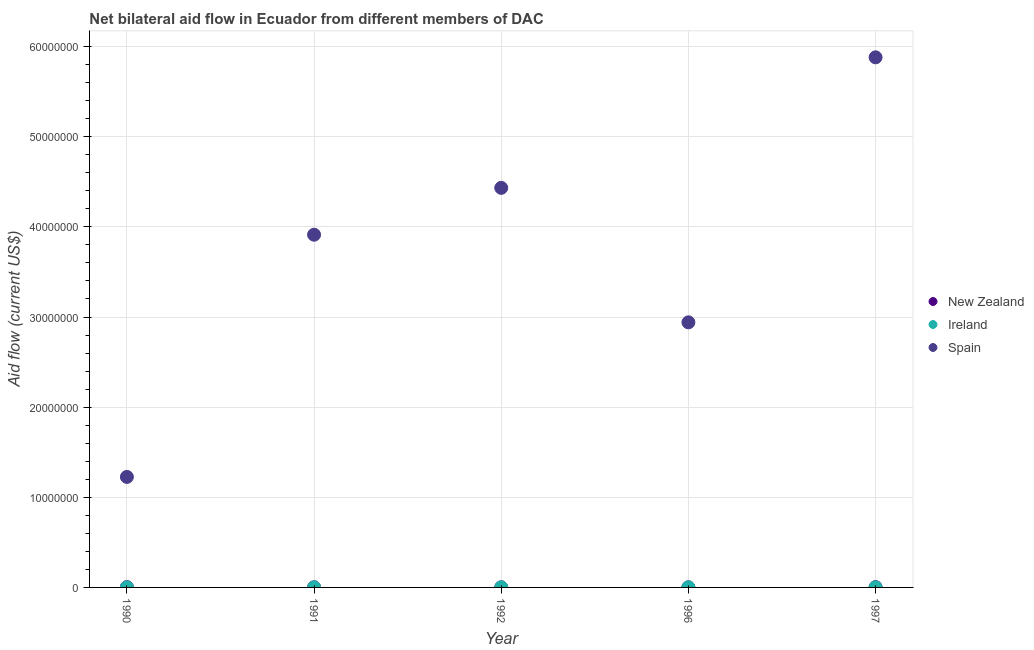Is the number of dotlines equal to the number of legend labels?
Your response must be concise. Yes. What is the amount of aid provided by new zealand in 1990?
Provide a succinct answer. 3.00e+04. Across all years, what is the maximum amount of aid provided by spain?
Offer a very short reply. 5.88e+07. Across all years, what is the minimum amount of aid provided by new zealand?
Make the answer very short. 10000. In which year was the amount of aid provided by new zealand maximum?
Your answer should be compact. 1990. In which year was the amount of aid provided by ireland minimum?
Your response must be concise. 1990. What is the total amount of aid provided by new zealand in the graph?
Provide a short and direct response. 9.00e+04. What is the difference between the amount of aid provided by spain in 1997 and the amount of aid provided by ireland in 1991?
Offer a terse response. 5.88e+07. In the year 1990, what is the difference between the amount of aid provided by spain and amount of aid provided by new zealand?
Your answer should be very brief. 1.22e+07. In how many years, is the amount of aid provided by new zealand greater than 14000000 US$?
Provide a succinct answer. 0. Is the amount of aid provided by ireland in 1991 less than that in 1992?
Keep it short and to the point. No. Is the difference between the amount of aid provided by ireland in 1991 and 1996 greater than the difference between the amount of aid provided by spain in 1991 and 1996?
Offer a very short reply. No. What is the difference between the highest and the lowest amount of aid provided by spain?
Your answer should be compact. 4.66e+07. Is the sum of the amount of aid provided by new zealand in 1991 and 1996 greater than the maximum amount of aid provided by ireland across all years?
Make the answer very short. Yes. Does the amount of aid provided by new zealand monotonically increase over the years?
Make the answer very short. No. What is the difference between two consecutive major ticks on the Y-axis?
Make the answer very short. 1.00e+07. Are the values on the major ticks of Y-axis written in scientific E-notation?
Keep it short and to the point. No. Does the graph contain any zero values?
Make the answer very short. No. Where does the legend appear in the graph?
Offer a very short reply. Center right. What is the title of the graph?
Your answer should be compact. Net bilateral aid flow in Ecuador from different members of DAC. What is the label or title of the X-axis?
Make the answer very short. Year. What is the label or title of the Y-axis?
Give a very brief answer. Aid flow (current US$). What is the Aid flow (current US$) in New Zealand in 1990?
Provide a succinct answer. 3.00e+04. What is the Aid flow (current US$) in Spain in 1990?
Offer a very short reply. 1.23e+07. What is the Aid flow (current US$) in Ireland in 1991?
Ensure brevity in your answer.  10000. What is the Aid flow (current US$) of Spain in 1991?
Your answer should be very brief. 3.91e+07. What is the Aid flow (current US$) in New Zealand in 1992?
Provide a short and direct response. 10000. What is the Aid flow (current US$) in Spain in 1992?
Offer a terse response. 4.43e+07. What is the Aid flow (current US$) in Spain in 1996?
Provide a short and direct response. 2.94e+07. What is the Aid flow (current US$) of Spain in 1997?
Keep it short and to the point. 5.88e+07. Across all years, what is the maximum Aid flow (current US$) in New Zealand?
Give a very brief answer. 3.00e+04. Across all years, what is the maximum Aid flow (current US$) in Spain?
Make the answer very short. 5.88e+07. Across all years, what is the minimum Aid flow (current US$) in New Zealand?
Ensure brevity in your answer.  10000. Across all years, what is the minimum Aid flow (current US$) in Ireland?
Offer a very short reply. 10000. Across all years, what is the minimum Aid flow (current US$) of Spain?
Make the answer very short. 1.23e+07. What is the total Aid flow (current US$) of Ireland in the graph?
Offer a very short reply. 5.00e+04. What is the total Aid flow (current US$) in Spain in the graph?
Your answer should be compact. 1.84e+08. What is the difference between the Aid flow (current US$) of Spain in 1990 and that in 1991?
Your answer should be very brief. -2.69e+07. What is the difference between the Aid flow (current US$) of Ireland in 1990 and that in 1992?
Provide a succinct answer. 0. What is the difference between the Aid flow (current US$) of Spain in 1990 and that in 1992?
Offer a very short reply. -3.21e+07. What is the difference between the Aid flow (current US$) of New Zealand in 1990 and that in 1996?
Your answer should be compact. 2.00e+04. What is the difference between the Aid flow (current US$) of Spain in 1990 and that in 1996?
Offer a terse response. -1.72e+07. What is the difference between the Aid flow (current US$) in Spain in 1990 and that in 1997?
Keep it short and to the point. -4.66e+07. What is the difference between the Aid flow (current US$) in Ireland in 1991 and that in 1992?
Keep it short and to the point. 0. What is the difference between the Aid flow (current US$) of Spain in 1991 and that in 1992?
Your response must be concise. -5.20e+06. What is the difference between the Aid flow (current US$) in Spain in 1991 and that in 1996?
Provide a short and direct response. 9.72e+06. What is the difference between the Aid flow (current US$) in Ireland in 1991 and that in 1997?
Your response must be concise. 0. What is the difference between the Aid flow (current US$) of Spain in 1991 and that in 1997?
Offer a very short reply. -1.97e+07. What is the difference between the Aid flow (current US$) of Spain in 1992 and that in 1996?
Your answer should be compact. 1.49e+07. What is the difference between the Aid flow (current US$) in Spain in 1992 and that in 1997?
Ensure brevity in your answer.  -1.45e+07. What is the difference between the Aid flow (current US$) of Spain in 1996 and that in 1997?
Ensure brevity in your answer.  -2.94e+07. What is the difference between the Aid flow (current US$) of New Zealand in 1990 and the Aid flow (current US$) of Spain in 1991?
Offer a terse response. -3.91e+07. What is the difference between the Aid flow (current US$) in Ireland in 1990 and the Aid flow (current US$) in Spain in 1991?
Your answer should be compact. -3.91e+07. What is the difference between the Aid flow (current US$) of New Zealand in 1990 and the Aid flow (current US$) of Ireland in 1992?
Give a very brief answer. 2.00e+04. What is the difference between the Aid flow (current US$) of New Zealand in 1990 and the Aid flow (current US$) of Spain in 1992?
Your answer should be very brief. -4.43e+07. What is the difference between the Aid flow (current US$) in Ireland in 1990 and the Aid flow (current US$) in Spain in 1992?
Make the answer very short. -4.43e+07. What is the difference between the Aid flow (current US$) in New Zealand in 1990 and the Aid flow (current US$) in Spain in 1996?
Your answer should be compact. -2.94e+07. What is the difference between the Aid flow (current US$) in Ireland in 1990 and the Aid flow (current US$) in Spain in 1996?
Your response must be concise. -2.94e+07. What is the difference between the Aid flow (current US$) of New Zealand in 1990 and the Aid flow (current US$) of Ireland in 1997?
Provide a short and direct response. 2.00e+04. What is the difference between the Aid flow (current US$) of New Zealand in 1990 and the Aid flow (current US$) of Spain in 1997?
Offer a terse response. -5.88e+07. What is the difference between the Aid flow (current US$) in Ireland in 1990 and the Aid flow (current US$) in Spain in 1997?
Provide a short and direct response. -5.88e+07. What is the difference between the Aid flow (current US$) of New Zealand in 1991 and the Aid flow (current US$) of Spain in 1992?
Your answer should be compact. -4.43e+07. What is the difference between the Aid flow (current US$) in Ireland in 1991 and the Aid flow (current US$) in Spain in 1992?
Your response must be concise. -4.43e+07. What is the difference between the Aid flow (current US$) in New Zealand in 1991 and the Aid flow (current US$) in Spain in 1996?
Provide a short and direct response. -2.94e+07. What is the difference between the Aid flow (current US$) in Ireland in 1991 and the Aid flow (current US$) in Spain in 1996?
Give a very brief answer. -2.94e+07. What is the difference between the Aid flow (current US$) of New Zealand in 1991 and the Aid flow (current US$) of Spain in 1997?
Offer a terse response. -5.88e+07. What is the difference between the Aid flow (current US$) of Ireland in 1991 and the Aid flow (current US$) of Spain in 1997?
Offer a very short reply. -5.88e+07. What is the difference between the Aid flow (current US$) of New Zealand in 1992 and the Aid flow (current US$) of Ireland in 1996?
Give a very brief answer. 0. What is the difference between the Aid flow (current US$) of New Zealand in 1992 and the Aid flow (current US$) of Spain in 1996?
Your answer should be compact. -2.94e+07. What is the difference between the Aid flow (current US$) in Ireland in 1992 and the Aid flow (current US$) in Spain in 1996?
Keep it short and to the point. -2.94e+07. What is the difference between the Aid flow (current US$) in New Zealand in 1992 and the Aid flow (current US$) in Spain in 1997?
Your answer should be compact. -5.88e+07. What is the difference between the Aid flow (current US$) of Ireland in 1992 and the Aid flow (current US$) of Spain in 1997?
Offer a very short reply. -5.88e+07. What is the difference between the Aid flow (current US$) in New Zealand in 1996 and the Aid flow (current US$) in Ireland in 1997?
Your answer should be compact. 0. What is the difference between the Aid flow (current US$) of New Zealand in 1996 and the Aid flow (current US$) of Spain in 1997?
Provide a succinct answer. -5.88e+07. What is the difference between the Aid flow (current US$) of Ireland in 1996 and the Aid flow (current US$) of Spain in 1997?
Provide a short and direct response. -5.88e+07. What is the average Aid flow (current US$) in New Zealand per year?
Keep it short and to the point. 1.80e+04. What is the average Aid flow (current US$) of Spain per year?
Keep it short and to the point. 3.68e+07. In the year 1990, what is the difference between the Aid flow (current US$) in New Zealand and Aid flow (current US$) in Ireland?
Your response must be concise. 2.00e+04. In the year 1990, what is the difference between the Aid flow (current US$) of New Zealand and Aid flow (current US$) of Spain?
Provide a short and direct response. -1.22e+07. In the year 1990, what is the difference between the Aid flow (current US$) of Ireland and Aid flow (current US$) of Spain?
Make the answer very short. -1.22e+07. In the year 1991, what is the difference between the Aid flow (current US$) of New Zealand and Aid flow (current US$) of Spain?
Your answer should be very brief. -3.91e+07. In the year 1991, what is the difference between the Aid flow (current US$) of Ireland and Aid flow (current US$) of Spain?
Your response must be concise. -3.91e+07. In the year 1992, what is the difference between the Aid flow (current US$) in New Zealand and Aid flow (current US$) in Spain?
Keep it short and to the point. -4.43e+07. In the year 1992, what is the difference between the Aid flow (current US$) in Ireland and Aid flow (current US$) in Spain?
Ensure brevity in your answer.  -4.43e+07. In the year 1996, what is the difference between the Aid flow (current US$) in New Zealand and Aid flow (current US$) in Spain?
Your answer should be very brief. -2.94e+07. In the year 1996, what is the difference between the Aid flow (current US$) in Ireland and Aid flow (current US$) in Spain?
Your response must be concise. -2.94e+07. In the year 1997, what is the difference between the Aid flow (current US$) of New Zealand and Aid flow (current US$) of Spain?
Ensure brevity in your answer.  -5.88e+07. In the year 1997, what is the difference between the Aid flow (current US$) in Ireland and Aid flow (current US$) in Spain?
Your answer should be compact. -5.88e+07. What is the ratio of the Aid flow (current US$) of Spain in 1990 to that in 1991?
Your response must be concise. 0.31. What is the ratio of the Aid flow (current US$) of New Zealand in 1990 to that in 1992?
Your answer should be very brief. 3. What is the ratio of the Aid flow (current US$) of Ireland in 1990 to that in 1992?
Provide a succinct answer. 1. What is the ratio of the Aid flow (current US$) of Spain in 1990 to that in 1992?
Offer a very short reply. 0.28. What is the ratio of the Aid flow (current US$) of Ireland in 1990 to that in 1996?
Ensure brevity in your answer.  1. What is the ratio of the Aid flow (current US$) of Spain in 1990 to that in 1996?
Ensure brevity in your answer.  0.42. What is the ratio of the Aid flow (current US$) in Ireland in 1990 to that in 1997?
Offer a very short reply. 1. What is the ratio of the Aid flow (current US$) in Spain in 1990 to that in 1997?
Keep it short and to the point. 0.21. What is the ratio of the Aid flow (current US$) in New Zealand in 1991 to that in 1992?
Make the answer very short. 1. What is the ratio of the Aid flow (current US$) of Ireland in 1991 to that in 1992?
Ensure brevity in your answer.  1. What is the ratio of the Aid flow (current US$) of Spain in 1991 to that in 1992?
Your answer should be compact. 0.88. What is the ratio of the Aid flow (current US$) of New Zealand in 1991 to that in 1996?
Your response must be concise. 1. What is the ratio of the Aid flow (current US$) in Spain in 1991 to that in 1996?
Your answer should be very brief. 1.33. What is the ratio of the Aid flow (current US$) in New Zealand in 1991 to that in 1997?
Make the answer very short. 0.33. What is the ratio of the Aid flow (current US$) of Spain in 1991 to that in 1997?
Ensure brevity in your answer.  0.67. What is the ratio of the Aid flow (current US$) of Ireland in 1992 to that in 1996?
Your answer should be compact. 1. What is the ratio of the Aid flow (current US$) in Spain in 1992 to that in 1996?
Your answer should be compact. 1.51. What is the ratio of the Aid flow (current US$) of Spain in 1992 to that in 1997?
Offer a very short reply. 0.75. What is the ratio of the Aid flow (current US$) in New Zealand in 1996 to that in 1997?
Offer a terse response. 0.33. What is the ratio of the Aid flow (current US$) of Spain in 1996 to that in 1997?
Ensure brevity in your answer.  0.5. What is the difference between the highest and the second highest Aid flow (current US$) in New Zealand?
Provide a succinct answer. 0. What is the difference between the highest and the second highest Aid flow (current US$) in Spain?
Offer a very short reply. 1.45e+07. What is the difference between the highest and the lowest Aid flow (current US$) in Spain?
Ensure brevity in your answer.  4.66e+07. 